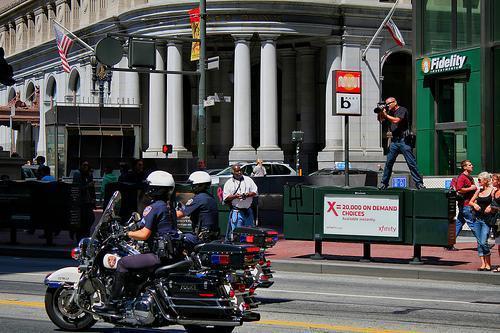How many motorcycles are in the photo?
Give a very brief answer. 2. How many american flags are in the scene?
Give a very brief answer. 1. 